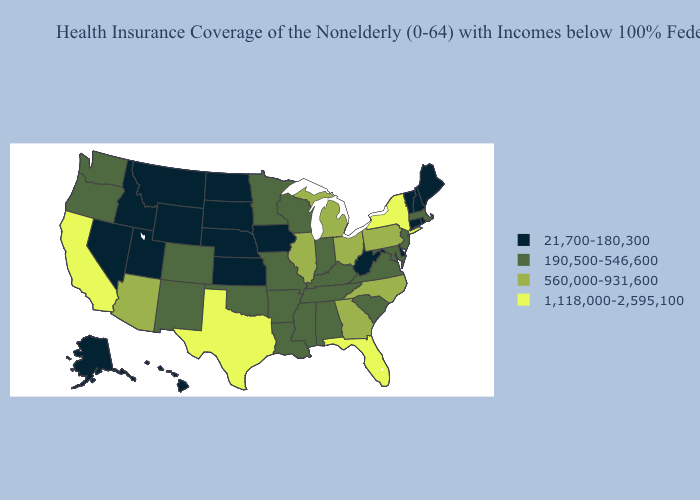Name the states that have a value in the range 1,118,000-2,595,100?
Write a very short answer. California, Florida, New York, Texas. Among the states that border Indiana , which have the lowest value?
Concise answer only. Kentucky. Does South Carolina have the lowest value in the USA?
Short answer required. No. Does North Carolina have the same value as Florida?
Give a very brief answer. No. What is the value of Pennsylvania?
Quick response, please. 560,000-931,600. What is the lowest value in states that border Louisiana?
Answer briefly. 190,500-546,600. Name the states that have a value in the range 1,118,000-2,595,100?
Give a very brief answer. California, Florida, New York, Texas. Does the map have missing data?
Answer briefly. No. What is the value of North Dakota?
Short answer required. 21,700-180,300. Name the states that have a value in the range 190,500-546,600?
Short answer required. Alabama, Arkansas, Colorado, Indiana, Kentucky, Louisiana, Maryland, Massachusetts, Minnesota, Mississippi, Missouri, New Jersey, New Mexico, Oklahoma, Oregon, South Carolina, Tennessee, Virginia, Washington, Wisconsin. Among the states that border West Virginia , which have the highest value?
Short answer required. Ohio, Pennsylvania. Does New York have the highest value in the Northeast?
Concise answer only. Yes. Name the states that have a value in the range 560,000-931,600?
Be succinct. Arizona, Georgia, Illinois, Michigan, North Carolina, Ohio, Pennsylvania. Among the states that border Nevada , does California have the highest value?
Quick response, please. Yes. Does Maine have a lower value than North Dakota?
Concise answer only. No. 